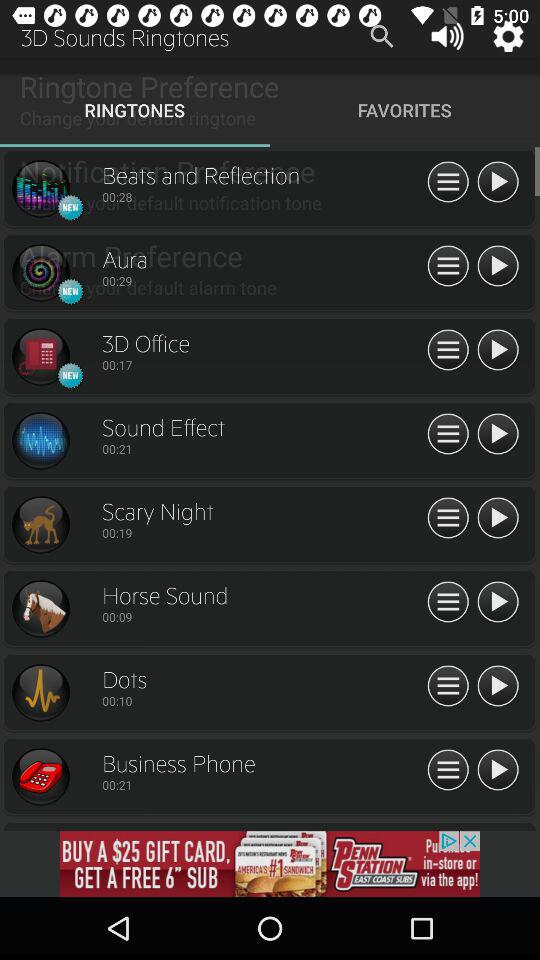What is the duration of dots? The duration of the dots is 00:10. 